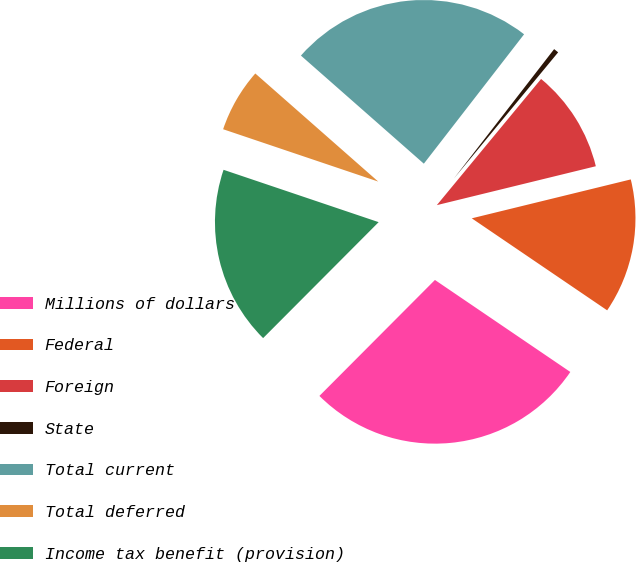Convert chart to OTSL. <chart><loc_0><loc_0><loc_500><loc_500><pie_chart><fcel>Millions of dollars<fcel>Federal<fcel>Foreign<fcel>State<fcel>Total current<fcel>Total deferred<fcel>Income tax benefit (provision)<nl><fcel>27.97%<fcel>13.32%<fcel>10.19%<fcel>0.5%<fcel>24.01%<fcel>6.3%<fcel>17.71%<nl></chart> 